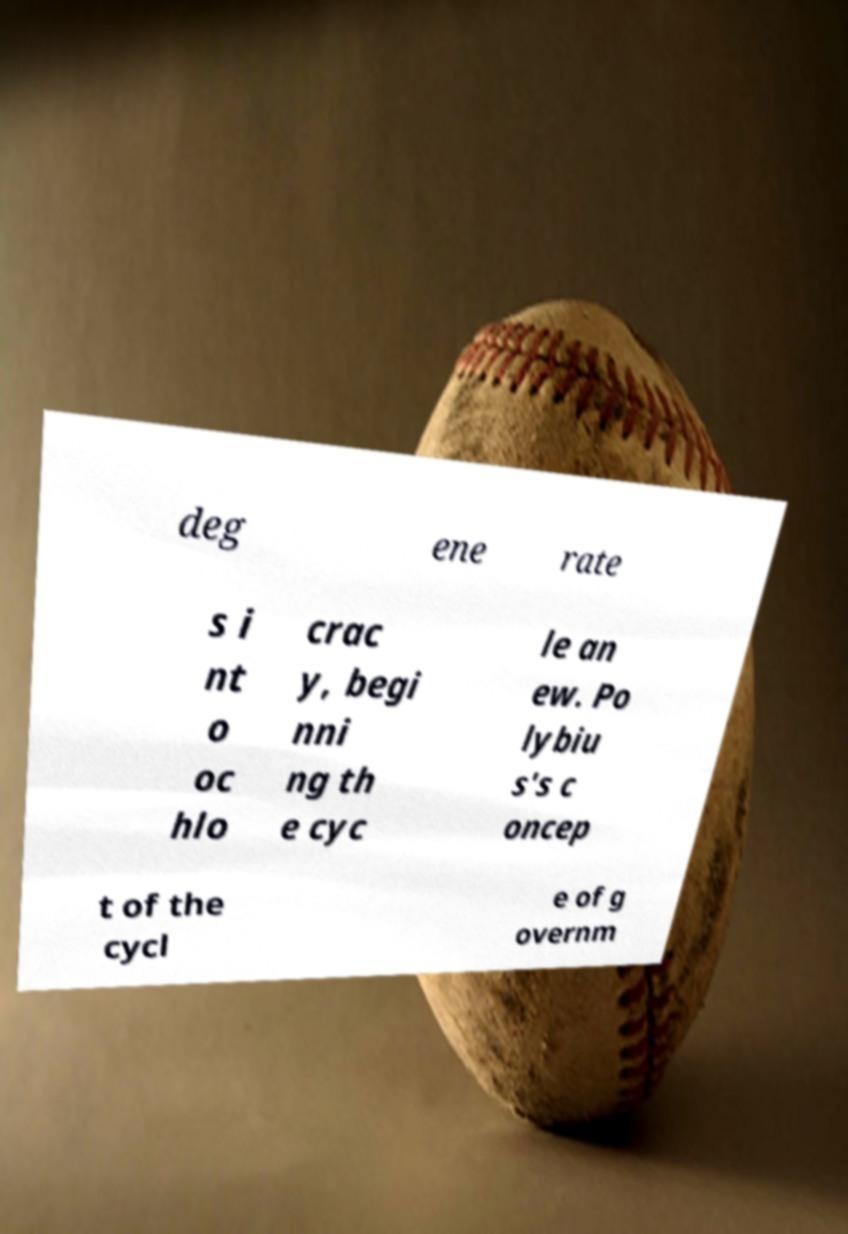Can you read and provide the text displayed in the image?This photo seems to have some interesting text. Can you extract and type it out for me? deg ene rate s i nt o oc hlo crac y, begi nni ng th e cyc le an ew. Po lybiu s's c oncep t of the cycl e of g overnm 